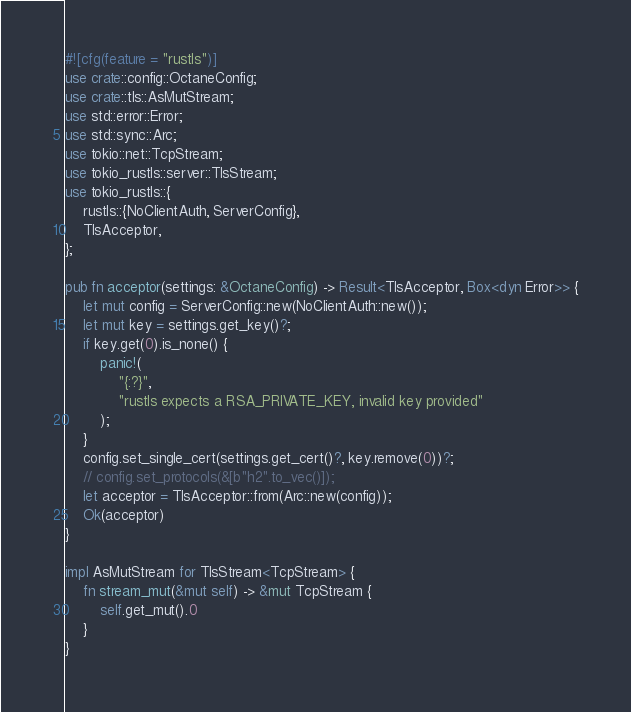Convert code to text. <code><loc_0><loc_0><loc_500><loc_500><_Rust_>#![cfg(feature = "rustls")]
use crate::config::OctaneConfig;
use crate::tls::AsMutStream;
use std::error::Error;
use std::sync::Arc;
use tokio::net::TcpStream;
use tokio_rustls::server::TlsStream;
use tokio_rustls::{
    rustls::{NoClientAuth, ServerConfig},
    TlsAcceptor,
};

pub fn acceptor(settings: &OctaneConfig) -> Result<TlsAcceptor, Box<dyn Error>> {
    let mut config = ServerConfig::new(NoClientAuth::new());
    let mut key = settings.get_key()?;
    if key.get(0).is_none() {
        panic!(
            "{:?}",
            "rustls expects a RSA_PRIVATE_KEY, invalid key provided"
        );
    }
    config.set_single_cert(settings.get_cert()?, key.remove(0))?;
    // config.set_protocols(&[b"h2".to_vec()]);
    let acceptor = TlsAcceptor::from(Arc::new(config));
    Ok(acceptor)
}

impl AsMutStream for TlsStream<TcpStream> {
    fn stream_mut(&mut self) -> &mut TcpStream {
        self.get_mut().0
    }
}
</code> 